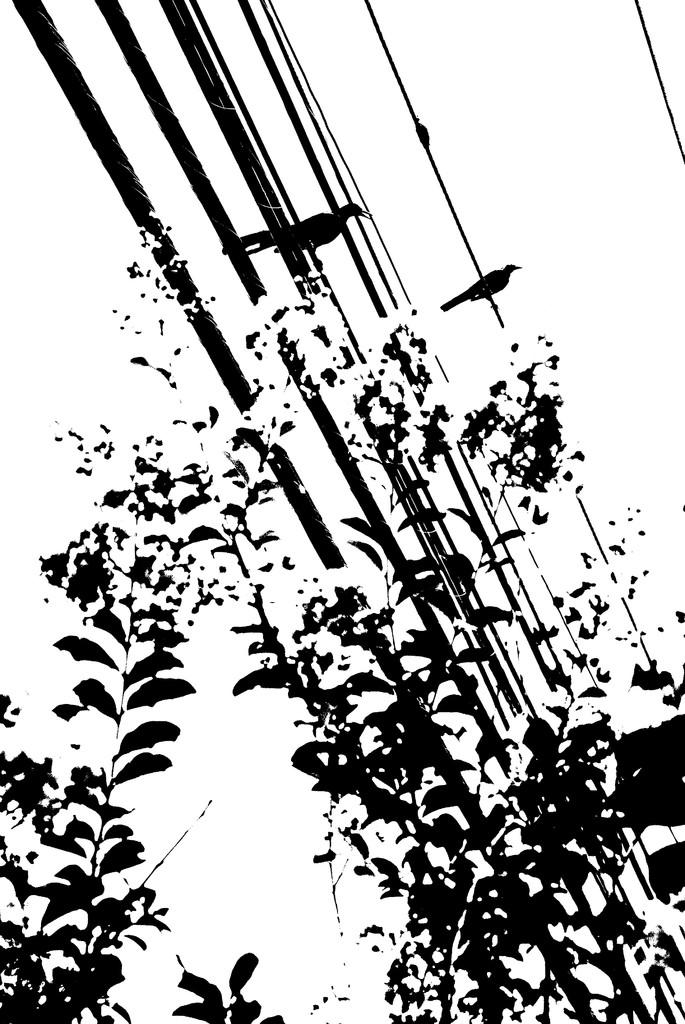What type of animals can be seen in the image? Birds can be seen in the image. What is the primary element in which the birds are situated? The birds are situated in a tree. What type of plastic material can be seen in the image? There is no plastic material present in the image. How many groups of birds are visible in the image? The image only shows birds, not groups of birds, so it is not possible to determine the number of groups. 